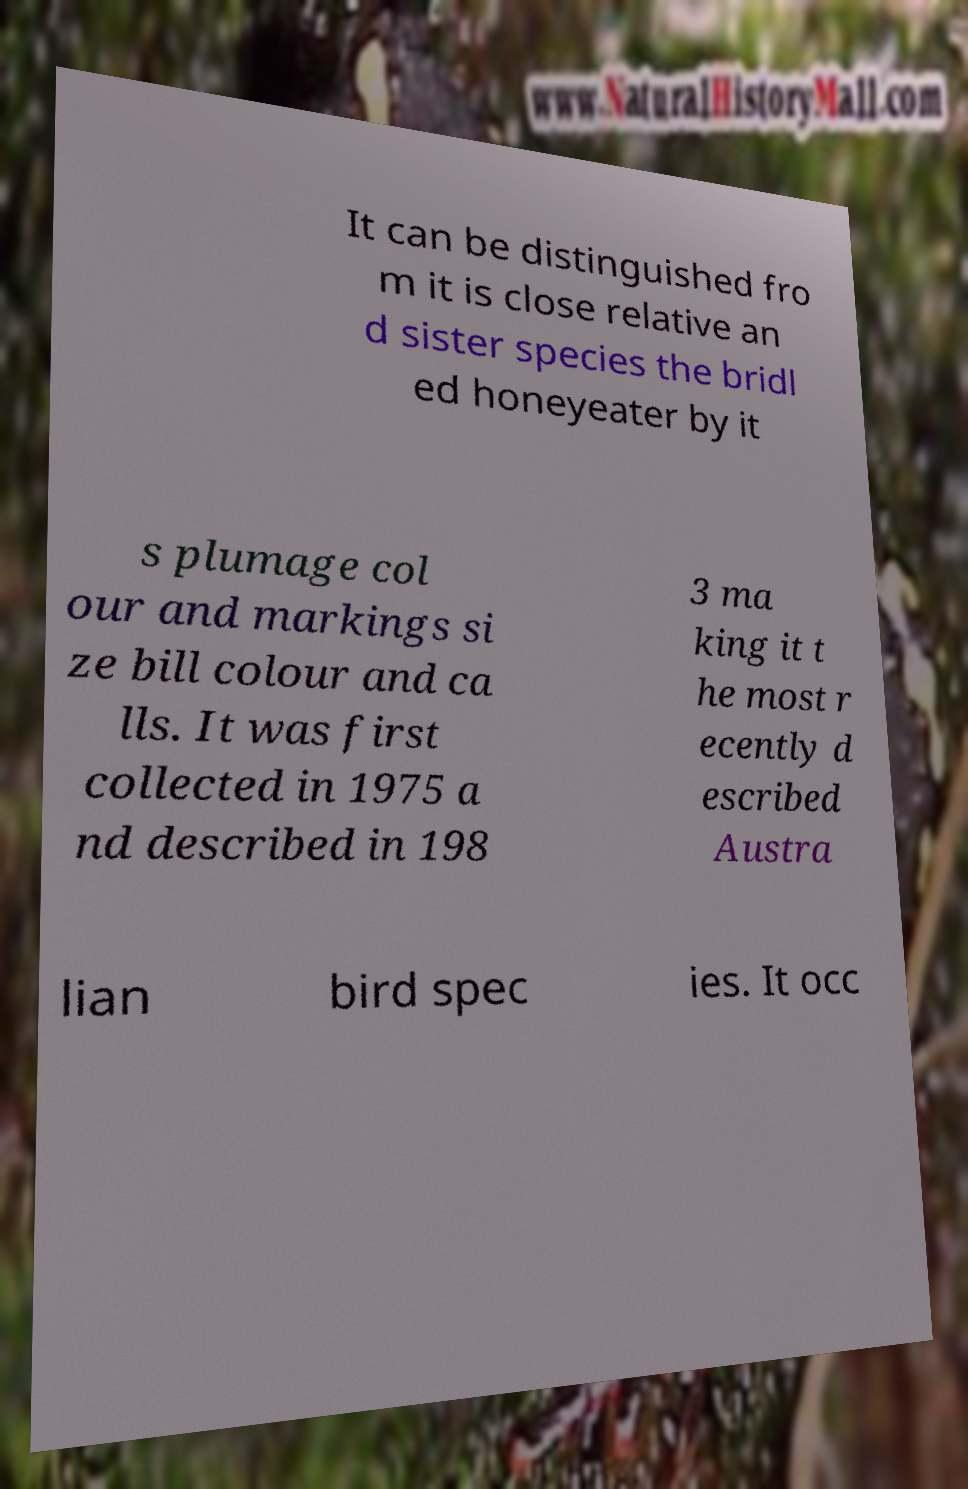There's text embedded in this image that I need extracted. Can you transcribe it verbatim? It can be distinguished fro m it is close relative an d sister species the bridl ed honeyeater by it s plumage col our and markings si ze bill colour and ca lls. It was first collected in 1975 a nd described in 198 3 ma king it t he most r ecently d escribed Austra lian bird spec ies. It occ 